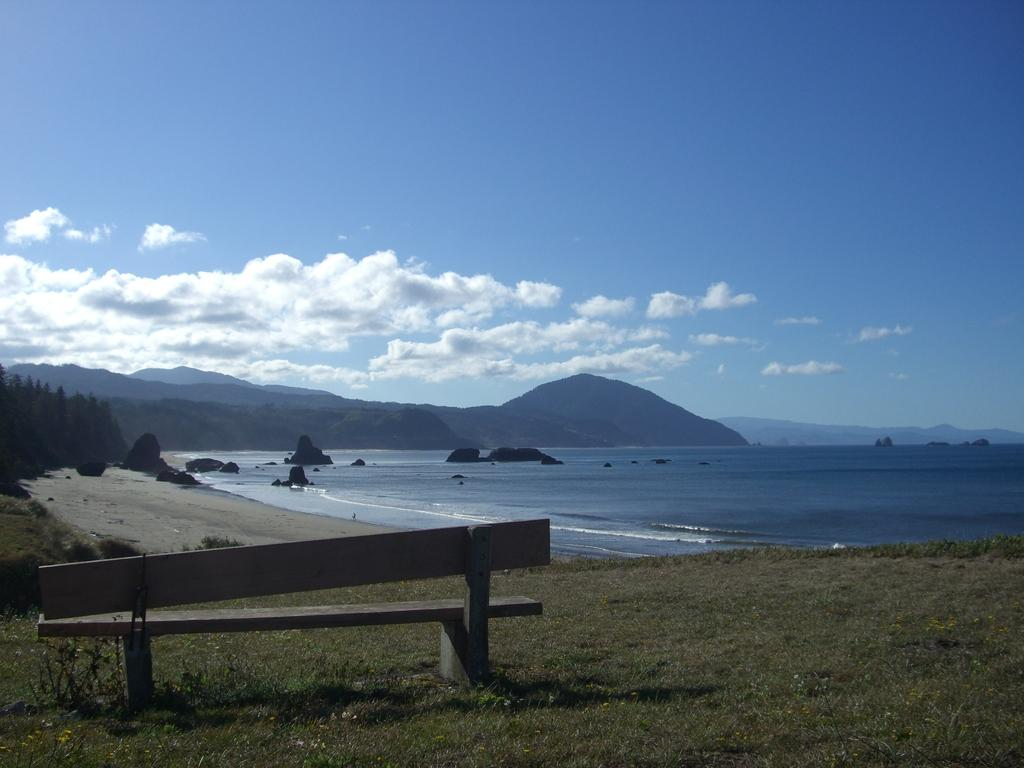What type of natural environment is depicted in the image? The image features a sea, mountains, and trees. Can you describe the landscape in the image? The landscape includes a sea, mountains, and trees. What is located in the foreground of the image? There is a bench on the grass in the foreground of the image. Where is the library located in the image? There is no library present in the image. What type of test can be seen being conducted in the image? There is no test or testing activity depicted in the image. 